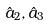Convert formula to latex. <formula><loc_0><loc_0><loc_500><loc_500>\hat { a } _ { 2 } , \hat { a } _ { 3 }</formula> 